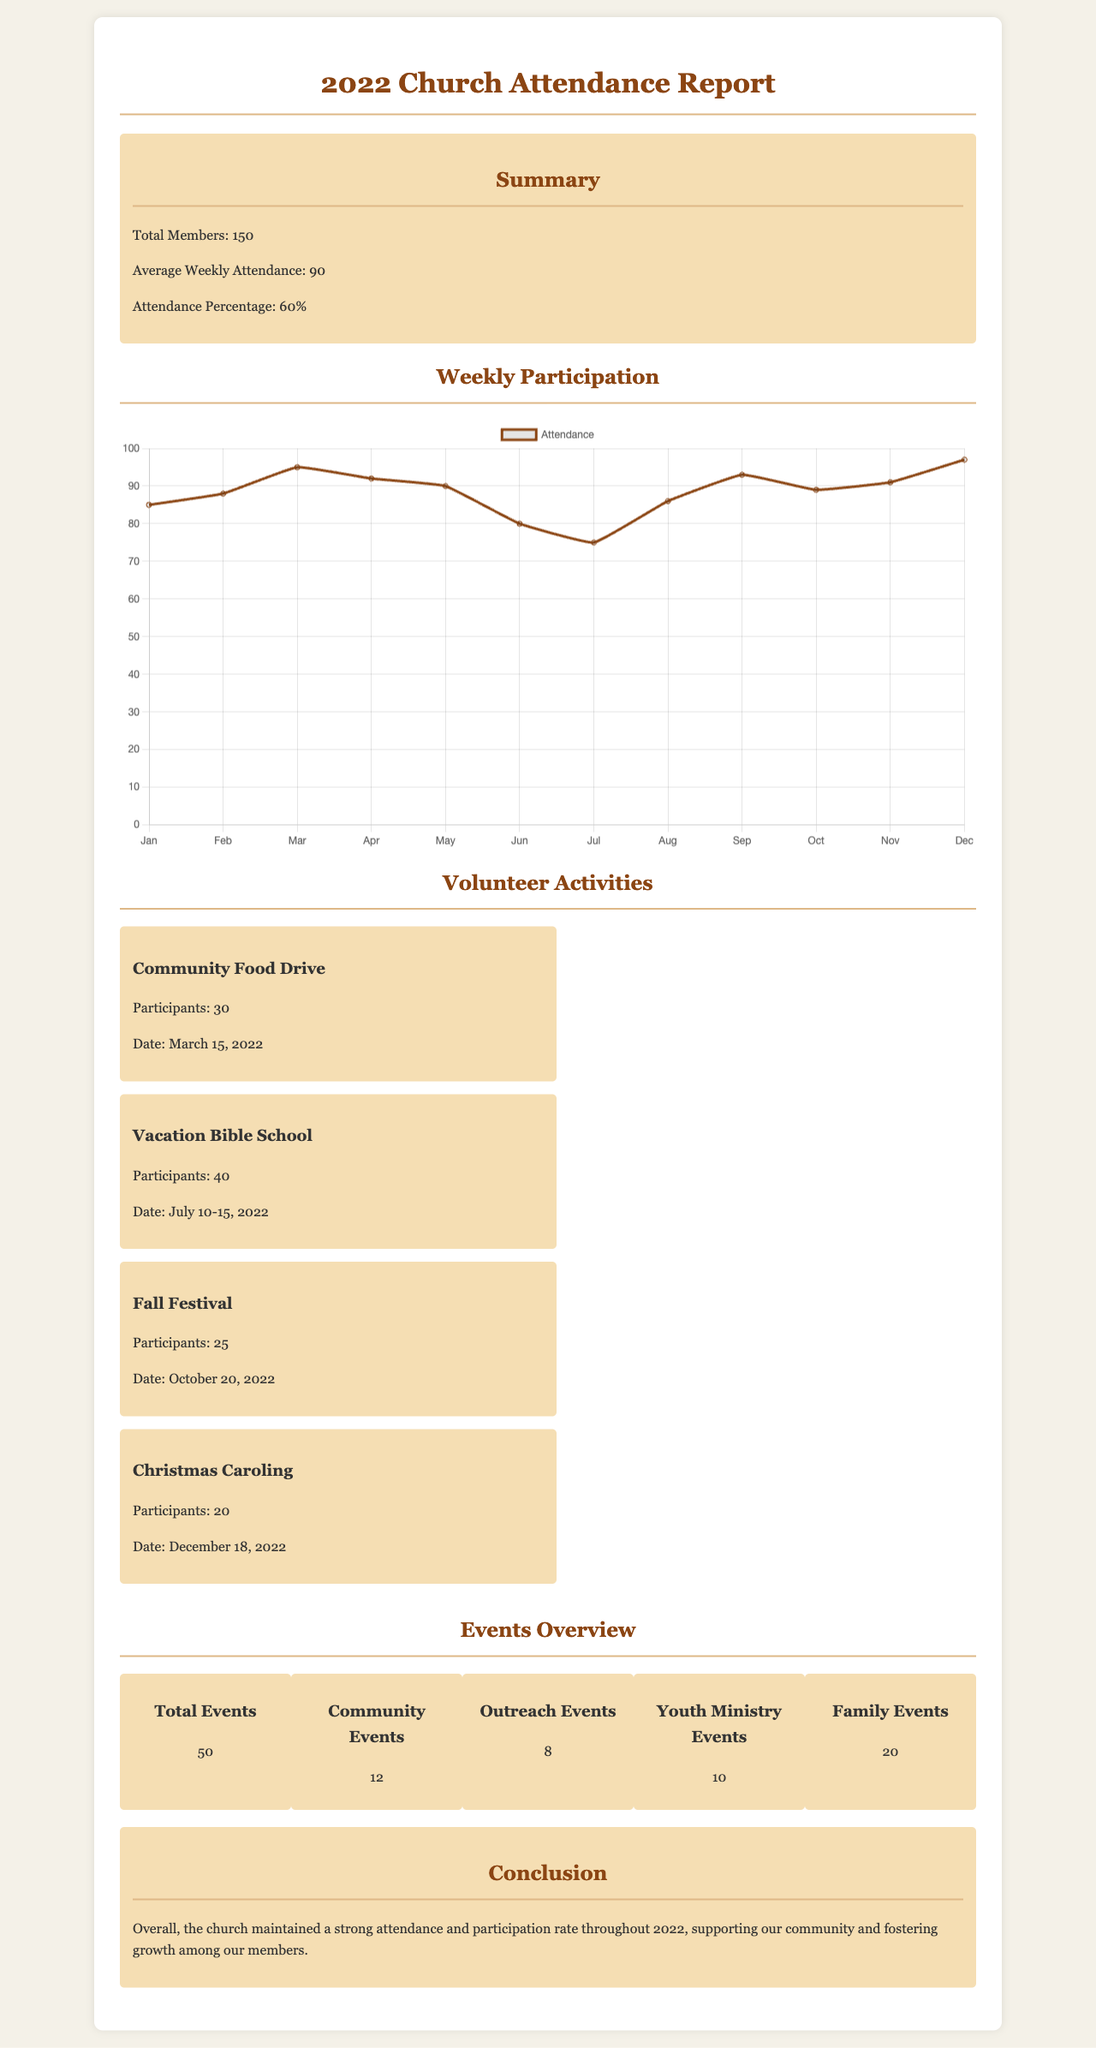What is the total number of church members? The document states that there are 150 total members in the church.
Answer: 150 What was the average weekly attendance? The report shows that the average weekly attendance was 90.
Answer: 90 What percentage of members attended church on average? The document indicates an attendance percentage of 60%.
Answer: 60% How many community events were held? The events overview section lists 12 community events.
Answer: 12 When did the Vacation Bible School take place? The date for the Vacation Bible School is provided as July 10-15, 2022.
Answer: July 10-15, 2022 What was the lowest attendance recorded in a month? The attendance chart shows the lowest attendance was in July with 75.
Answer: 75 How many total events were there in 2022? According to the events overview, there were 50 total events.
Answer: 50 Which volunteer activity had the highest participation? The document lists the Vacation Bible School with 40 participants.
Answer: Vacation Bible School What activity took place on December 18, 2022? The document mentions Christmas Caroling was held on that date.
Answer: Christmas Caroling 